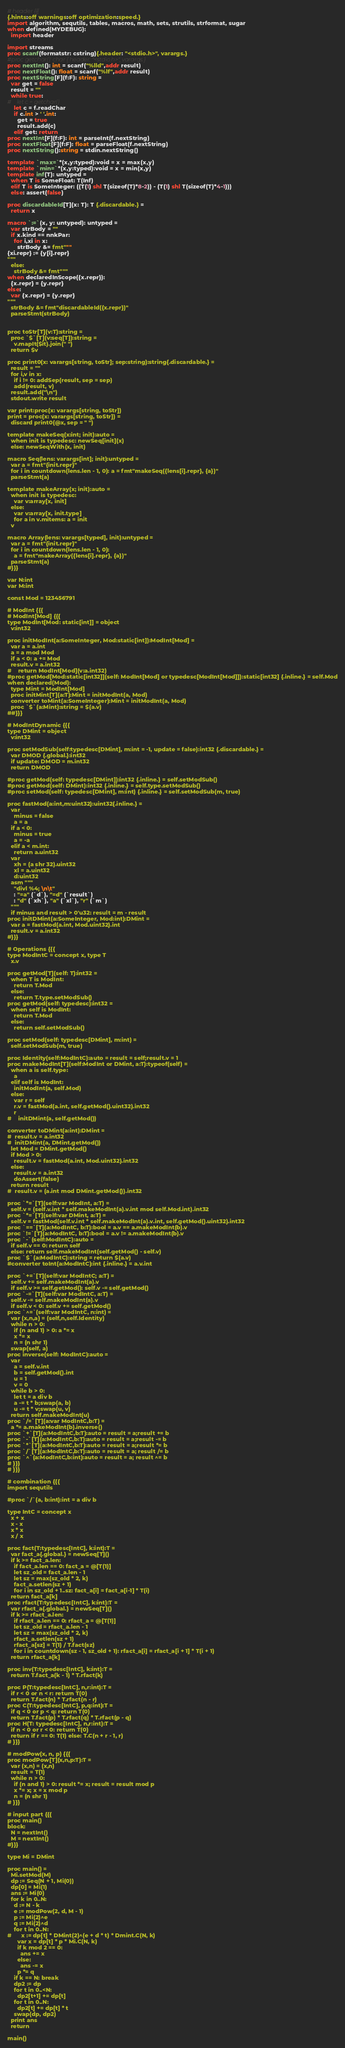Convert code to text. <code><loc_0><loc_0><loc_500><loc_500><_Nim_># header {{{
{.hints:off warnings:off optimization:speed.}
import algorithm, sequtils, tables, macros, math, sets, strutils, strformat, sugar
when defined(MYDEBUG):
  import header

import streams
proc scanf(formatstr: cstring){.header: "<stdio.h>", varargs.}
#proc getchar(): char {.header: "<stdio.h>", varargs.}
proc nextInt(): int = scanf("%lld",addr result)
proc nextFloat(): float = scanf("%lf",addr result)
proc nextString[F](f:F): string =
  var get = false
  result = ""
  while true:
#    let c = getchar()
    let c = f.readChar
    if c.int > ' '.int:
      get = true
      result.add(c)
    elif get: return
proc nextInt[F](f:F): int = parseInt(f.nextString)
proc nextFloat[F](f:F): float = parseFloat(f.nextString)
proc nextString():string = stdin.nextString()

template `max=`*(x,y:typed):void = x = max(x,y)
template `min=`*(x,y:typed):void = x = min(x,y)
template inf(T): untyped = 
  when T is SomeFloat: T(Inf)
  elif T is SomeInteger: ((T(1) shl T(sizeof(T)*8-2)) - (T(1) shl T(sizeof(T)*4-1)))
  else: assert(false)

proc discardableId[T](x: T): T {.discardable.} =
  return x

macro `:=`(x, y: untyped): untyped =
  var strBody = ""
  if x.kind == nnkPar:
    for i,xi in x:
      strBody &= fmt"""
{xi.repr} := {y[i].repr}
"""
  else:
    strBody &= fmt"""
when declaredInScope({x.repr}):
  {x.repr} = {y.repr}
else:
  var {x.repr} = {y.repr}
"""
  strBody &= fmt"discardableId({x.repr})"
  parseStmt(strBody)


proc toStr[T](v:T):string =
  proc `$`[T](v:seq[T]):string =
    v.mapIt($it).join(" ")
  return $v

proc print0(x: varargs[string, toStr]; sep:string):string{.discardable.} =
  result = ""
  for i,v in x:
    if i != 0: addSep(result, sep = sep)
    add(result, v)
  result.add("\n")
  stdout.write result

var print:proc(x: varargs[string, toStr])
print = proc(x: varargs[string, toStr]) =
  discard print0(@x, sep = " ")

template makeSeq(x:int; init):auto =
  when init is typedesc: newSeq[init](x)
  else: newSeqWith(x, init)

macro Seq(lens: varargs[int]; init):untyped =
  var a = fmt"{init.repr}"
  for i in countdown(lens.len - 1, 0): a = fmt"makeSeq({lens[i].repr}, {a})"
  parseStmt(a)

template makeArray(x; init):auto =
  when init is typedesc:
    var v:array[x, init]
  else:
    var v:array[x, init.type]
    for a in v.mitems: a = init
  v

macro Array(lens: varargs[typed], init):untyped =
  var a = fmt"{init.repr}"
  for i in countdown(lens.len - 1, 0):
    a = fmt"makeArray({lens[i].repr}, {a})"
  parseStmt(a)
#}}}

var N:int
var M:int

const Mod = 123456791

# ModInt {{{
# ModInt[Mod] {{{
type ModInt[Mod: static[int]] = object
  v:int32

proc initModInt(a:SomeInteger, Mod:static[int]):ModInt[Mod] =
  var a = a.int
  a = a mod Mod
  if a < 0: a += Mod
  result.v = a.int32
#    return ModInt[Mod](v:a.int32)
#proc getMod[Mod:static[int32]](self: ModInt[Mod] or typedesc[ModInt[Mod]]):static[int32] {.inline.} = self.Mod
when declared(Mod):
  type Mint = ModInt[Mod]
  proc initMint[T](a:T):Mint = initModInt(a, Mod)
  converter toMint(a:SomeInteger):Mint = initModInt(a, Mod)
  proc `$`(a:Mint):string = $(a.v)
##}}}

# ModIntDynamic {{{
type DMint = object
  v:int32

proc setModSub(self:typedesc[DMint], m:int = -1, update = false):int32 {.discardable.} =
  var DMOD {.global.}:int32
  if update: DMOD = m.int32
  return DMOD

#proc getMod(self: typedesc[DMint]):int32 {.inline.} = self.setModSub()
#proc getMod(self: DMint):int32 {.inline.} = self.type.setModSub()
#proc setMod(self: typedesc[DMint], m:int) {.inline.} = self.setModSub(m, true)

proc fastMod(a:int,m:uint32):uint32{.inline.} =
  var
    minus = false
    a = a
  if a < 0:
    minus = true
    a = -a
  elif a < m.int:
    return a.uint32
  var
    xh = (a shr 32).uint32
    xl = a.uint32
    d:uint32
  asm """
    "divl %4; \n\t"
    : "=a" (`d`), "=d" (`result`)
    : "d" (`xh`), "a" (`xl`), "r" (`m`)
  """
  if minus and result > 0'u32: result = m - result
proc initDMint(a:SomeInteger, Mod:int):DMint =
  var a = fastMod(a.int, Mod.uint32).int
  result.v = a.int32
#}}}

# Operations {{{
type ModIntC = concept x, type T
  x.v

proc getMod[T](self: T):int32 =
  when T is ModInt:
    return T.Mod
  else:
    return T.type.setModSub()
proc getMod(self: typedesc):int32 =
  when self is ModInt:
    return T.Mod
  else:
    return self.setModSub()

proc setMod(self: typedesc[DMint], m:int) =
  self.setModSub(m, true)

proc Identity(self:ModIntC):auto = result = self;result.v = 1
proc makeModInt[T](self:ModInt or DMint, a:T):typeof(self) =
  when a is self.type:
    a
  elif self is ModInt:
    initModInt(a, self.Mod)
  else:
    var r = self
    r.v = fastMod(a.int, self.getMod().uint32).int32
    r
#    initDMint(a, self.getMod())

converter toDMint(a:int):DMint =
#  result.v = a.int32
#  initDMint(a, DMint.getMod())
  let Mod = DMint.getMod()
  if Mod > 0:
    result.v = fastMod(a.int, Mod.uint32).int32
  else:
    result.v = a.int32
    doAssert(false)
  return result
#  result.v = (a.int mod DMint.getMod()).int32

proc `*=`[T](self:var ModInt, a:T) =
  self.v = (self.v.int * self.makeModInt(a).v.int mod self.Mod.int).int32
proc `*=`[T](self:var DMint, a:T) =
  self.v = fastMod(self.v.int * self.makeModInt(a).v.int, self.getMod().uint32).int32
proc `==`[T](a:ModIntC, b:T):bool = a.v == a.makeModInt(b).v
proc `!=`[T](a:ModIntC, b:T):bool = a.v != a.makeModInt(b).v
proc `-`(self:ModIntC):auto =
  if self.v == 0: return self
  else: return self.makeModInt(self.getMod() - self.v)
proc `$`(a:ModIntC):string = return $(a.v)
#converter toInt(a:ModIntC):int {.inline.} = a.v.int

proc `+=`[T](self:var ModIntC; a:T) =
  self.v += self.makeModInt(a).v
  if self.v >= self.getMod(): self.v -= self.getMod()
proc `-=`[T](self:var ModIntC, a:T) =
  self.v -= self.makeModInt(a).v
  if self.v < 0: self.v += self.getMod()
proc `^=`(self:var ModIntC, n:int) =
  var (x,n,a) = (self,n,self.Identity)
  while n > 0:
    if (n and 1) > 0: a *= x
    x *= x
    n = (n shr 1)
  swap(self, a)
proc inverse(self: ModIntC):auto =
  var
    a = self.v.int
    b = self.getMod().int
    u = 1
    v = 0
  while b > 0:
    let t = a div b
    a -= t * b;swap(a, b)
    u -= t * v;swap(u, v)
  return self.makeModInt(u)
proc `/=`[T](a:var ModIntC,b:T) =
  a *= a.makeModInt(b).inverse()
proc `+`[T](a:ModIntC,b:T):auto = result = a;result += b
proc `-`[T](a:ModIntC,b:T):auto = result = a;result -= b
proc `*`[T](a:ModIntC,b:T):auto = result = a;result *= b
proc `/`[T](a:ModIntC,b:T):auto = result = a; result /= b
proc `^`(a:ModIntC,b:int):auto = result = a; result ^= b
# }}}
# }}}

# combination {{{
import sequtils

#proc `/`(a, b:int):int = a div b

type IntC = concept x
  x + x
  x - x
  x * x
  x / x

proc fact(T:typedesc[IntC], k:int):T =
  var fact_a{.global.} = newSeq[T]()
  if k >= fact_a.len:
    if fact_a.len == 0: fact_a = @[T(1)]
    let sz_old = fact_a.len - 1
    let sz = max(sz_old * 2, k)
    fact_a.setlen(sz + 1)
    for i in sz_old + 1..sz: fact_a[i] = fact_a[i-1] * T(i)
  return fact_a[k]
proc rfact(T:typedesc[IntC], k:int):T =
  var rfact_a{.global.} = newSeq[T]()
  if k >= rfact_a.len:
    if rfact_a.len == 0: rfact_a = @[T(1)]
    let sz_old = rfact_a.len - 1
    let sz = max(sz_old * 2, k)
    rfact_a.setlen(sz + 1)
    rfact_a[sz] = T(1) / T.fact(sz)
    for i in countdown(sz - 1, sz_old + 1): rfact_a[i] = rfact_a[i + 1] * T(i + 1)
  return rfact_a[k]

proc inv(T:typedesc[IntC], k:int):T =
  return T.fact_a(k - 1) * T.rfact(k)

proc P(T:typedesc[IntC], n,r:int):T =
  if r < 0 or n < r: return T(0)
  return T.fact(n) * T.rfact(n - r)
proc C(T:typedesc[IntC], p,q:int):T =
  if q < 0 or p < q: return T(0)
  return T.fact(p) * T.rfact(q) * T.rfact(p - q)
proc H(T: typedesc[IntC], n,r:int):T =
  if n < 0 or r < 0: return T(0)
  return if r == 0: T(1) else: T.C(n + r - 1, r)
# }}}

# modPow(x, n, p) {{{
proc modPow[T](x,n,p:T):T =
  var (x,n) = (x,n)
  result = T(1)
  while n > 0:
    if (n and 1) > 0: result *= x; result = result mod p
    x *= x; x = x mod p
    n = (n shr 1)
# }}}

# input part {{{
proc main()
block:
  N = nextInt()
  M = nextInt()
#}}}

type Mi = DMint

proc main() =
  Mi.setMod(M)
  dp := Seq(N + 1, Mi(0))
  dp[0] = Mi(1)
  ans := Mi(0)
  for k in 0..N:
    d := N - k
    e := modPow(2, d, M - 1)
    p := Mi(2)^e
    q := Mi(2)^d
    for t in 0..N:
#      x := dp[t] * DMint(2)^(e + d * t) * Dmint.C(N, k)
      var x = dp[t] * p * Mi.C(N, k)
      if k mod 2 == 0:
        ans += x
      else:
        ans -= x
      p *= q
    if k == N: break
    dp2 := dp
    for t in 0..<N:
      dp2[t+1] += dp[t]
    for t in 0..N:
      dp2[t] += dp[t] * t
    swap(dp, dp2)
  print ans
  return

main()</code> 